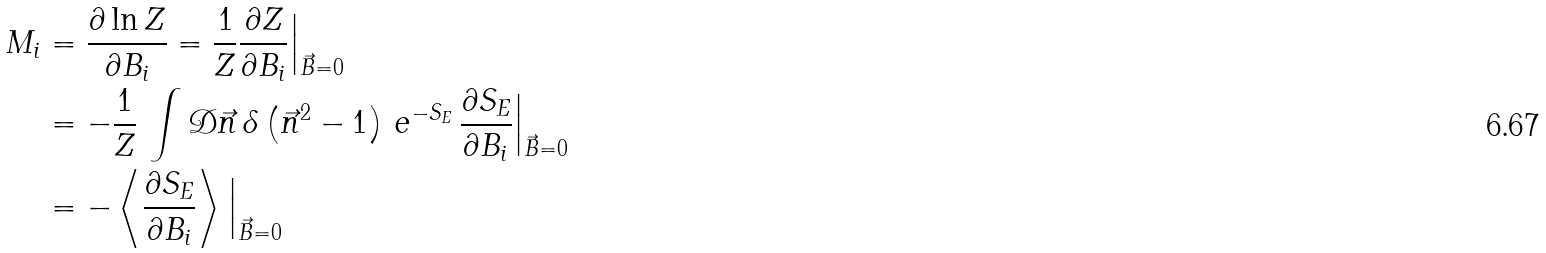<formula> <loc_0><loc_0><loc_500><loc_500>M _ { i } & = \frac { \partial \ln Z } { \partial B _ { i } } = \frac { 1 } { Z } \frac { \partial Z } { \partial B _ { i } } \Big | _ { \vec { B } = 0 } \\ & = - \frac { 1 } { Z } \, \int \mathcal { D } \vec { n } \, \delta \left ( \vec { n } ^ { 2 } - 1 \right ) \, e ^ { - S _ { E } } \, \frac { \partial S _ { E } } { \partial B _ { i } } \Big | _ { \vec { B } = 0 } \\ & = - \left \langle \frac { \partial S _ { E } } { \partial B _ { i } } \right \rangle \Big | _ { \vec { B } = 0 }</formula> 